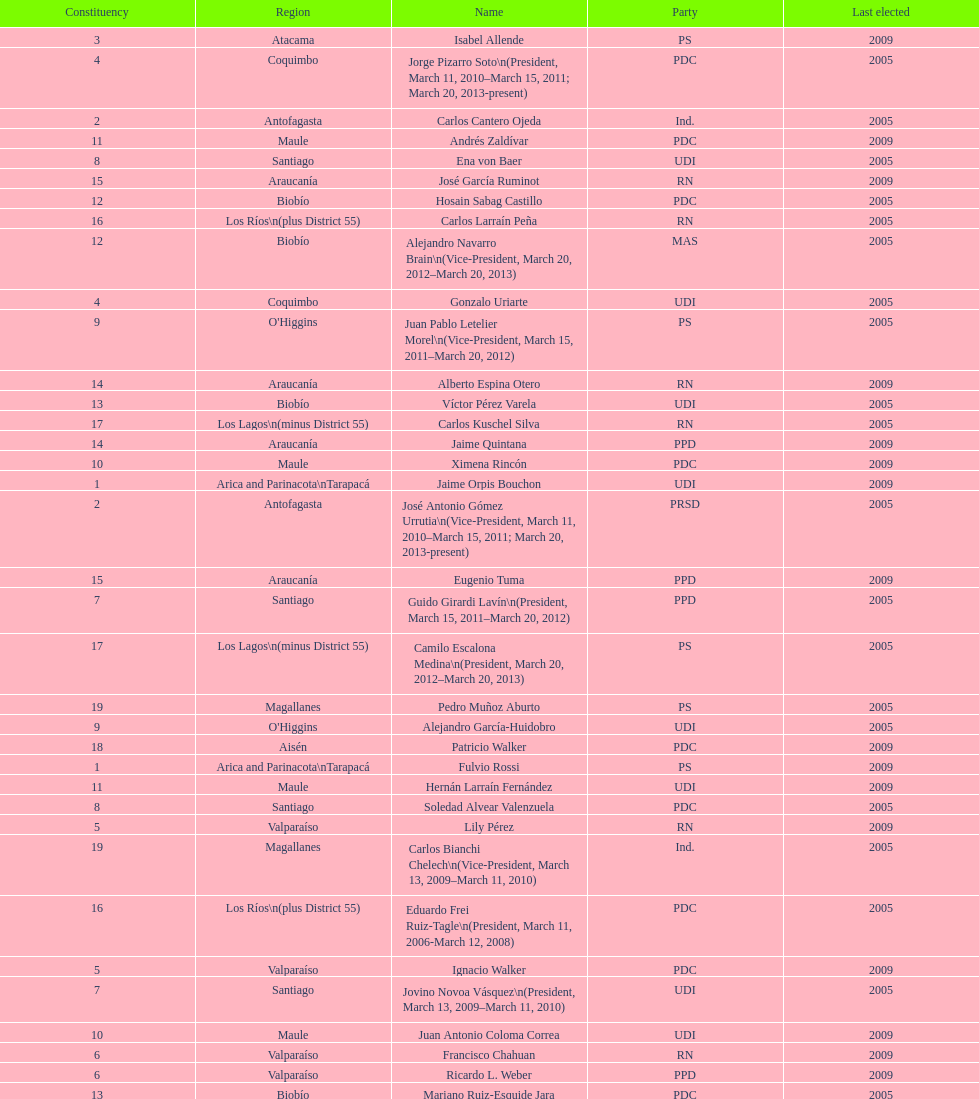What is the year gap between constituency 1 and constituency 2? 4 years. 